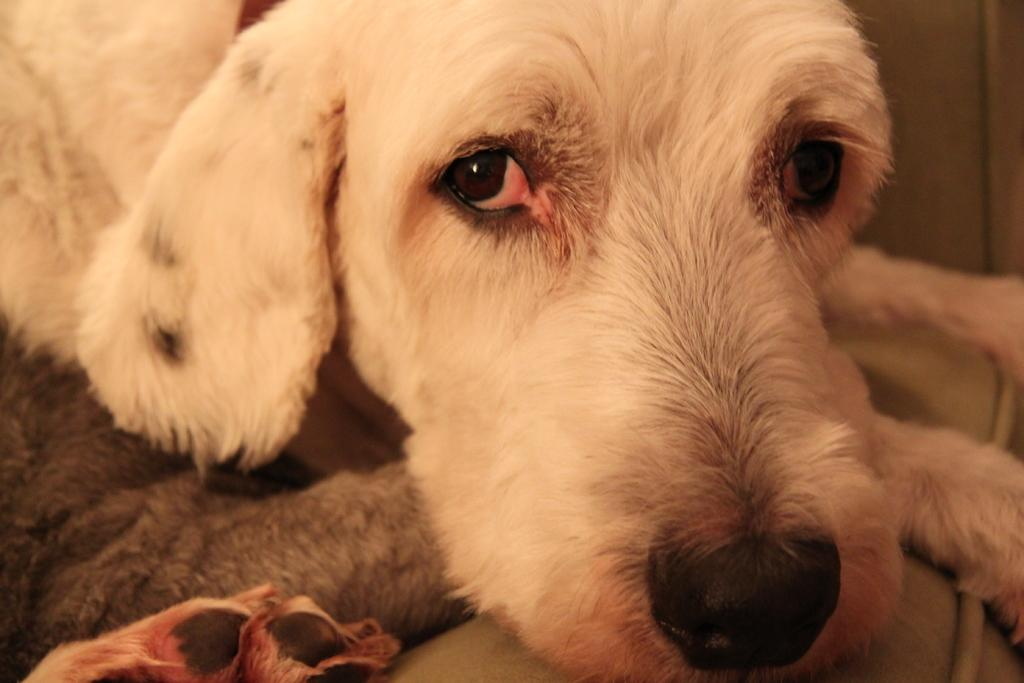What type of animal is in the image? There is a dog in the image. What color is the dog? The dog is white in color. What type of flowers are being held by the dog in the image? There are no flowers or any other objects being held by the dog in the image. 